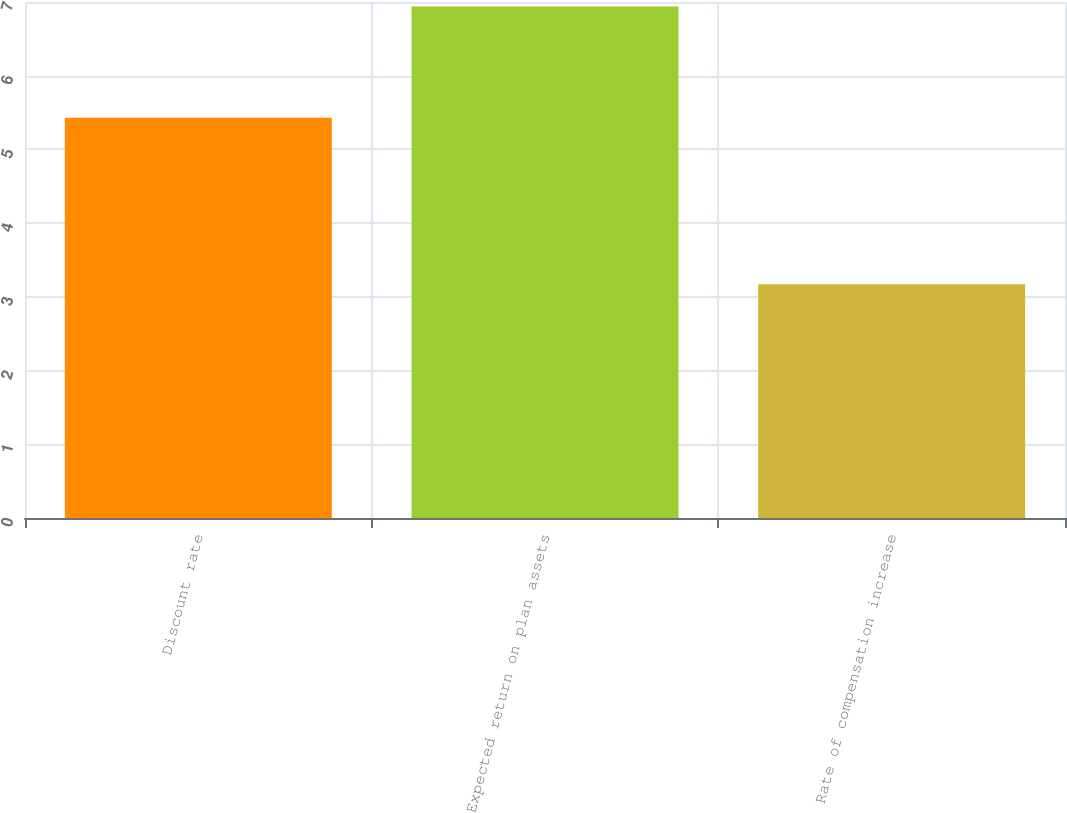<chart> <loc_0><loc_0><loc_500><loc_500><bar_chart><fcel>Discount rate<fcel>Expected return on plan assets<fcel>Rate of compensation increase<nl><fcel>5.43<fcel>6.94<fcel>3.17<nl></chart> 